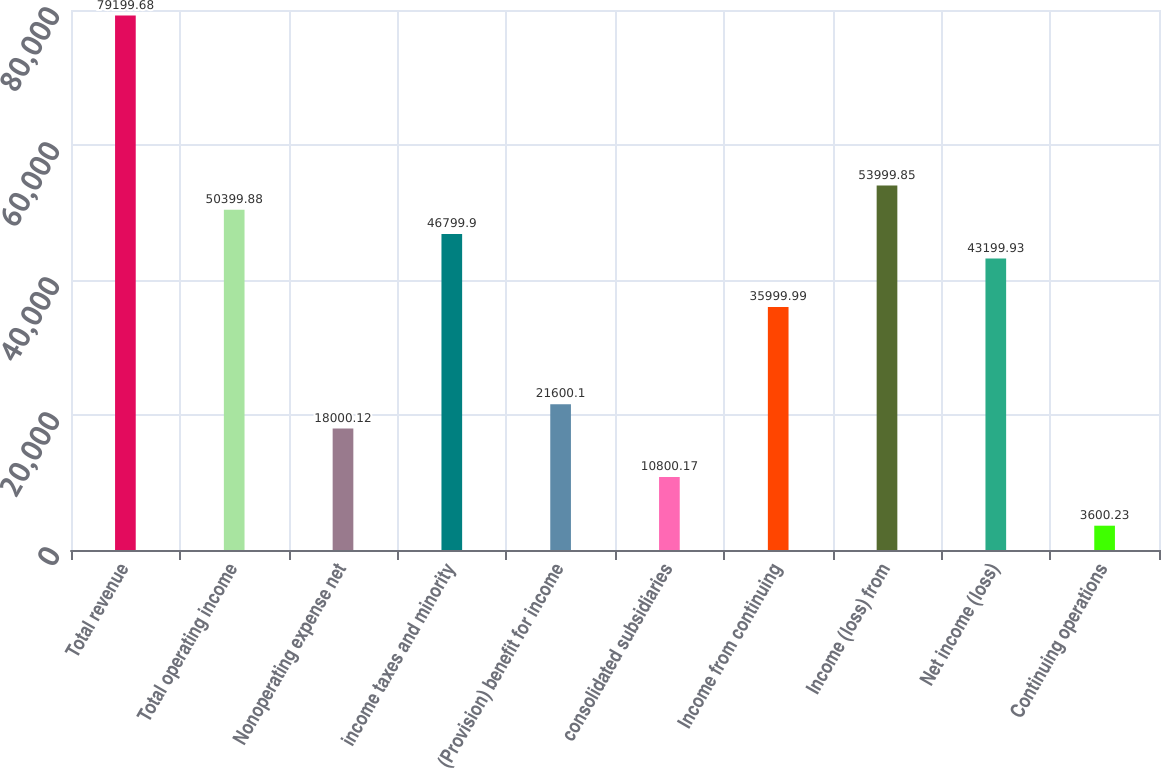Convert chart to OTSL. <chart><loc_0><loc_0><loc_500><loc_500><bar_chart><fcel>Total revenue<fcel>Total operating income<fcel>Nonoperating expense net<fcel>income taxes and minority<fcel>(Provision) benefit for income<fcel>consolidated subsidiaries<fcel>Income from continuing<fcel>Income (loss) from<fcel>Net income (loss)<fcel>Continuing operations<nl><fcel>79199.7<fcel>50399.9<fcel>18000.1<fcel>46799.9<fcel>21600.1<fcel>10800.2<fcel>36000<fcel>53999.8<fcel>43199.9<fcel>3600.23<nl></chart> 